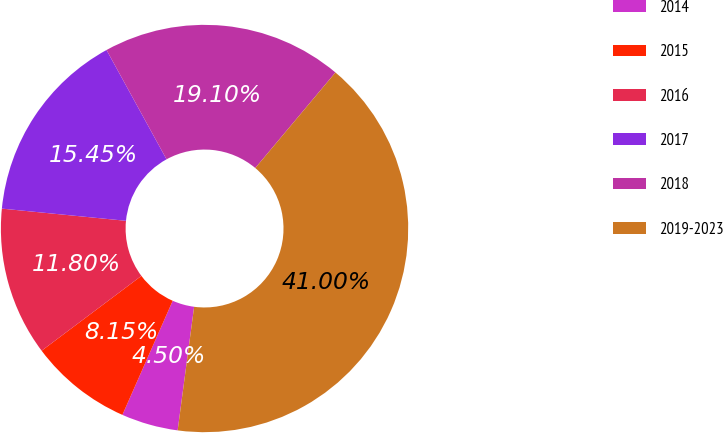Convert chart to OTSL. <chart><loc_0><loc_0><loc_500><loc_500><pie_chart><fcel>2014<fcel>2015<fcel>2016<fcel>2017<fcel>2018<fcel>2019-2023<nl><fcel>4.5%<fcel>8.15%<fcel>11.8%<fcel>15.45%<fcel>19.1%<fcel>41.0%<nl></chart> 